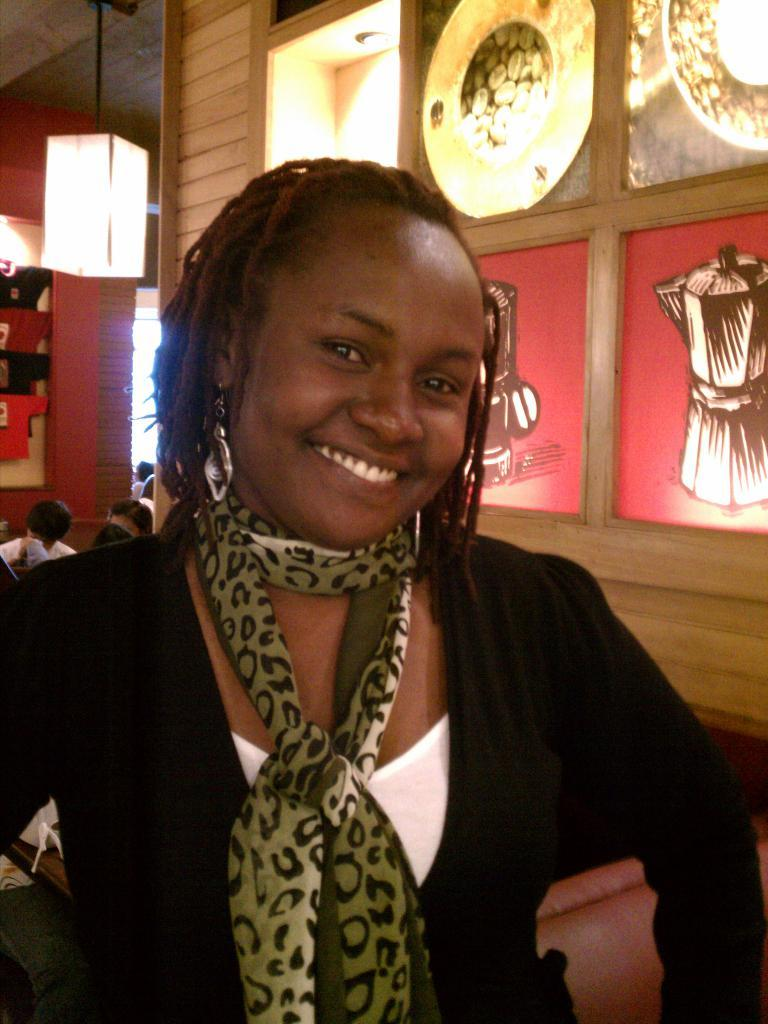What is the person in the image doing? The person in the image is smiling. What can be seen on the wooden wall in the background? There are frames attached to the wooden wall in the background. What is visible in the background besides the wooden wall? There are lights and a group of people visible in the background. What type of substance is being used by the company in the image? There is no mention of a substance or a company in the image. 